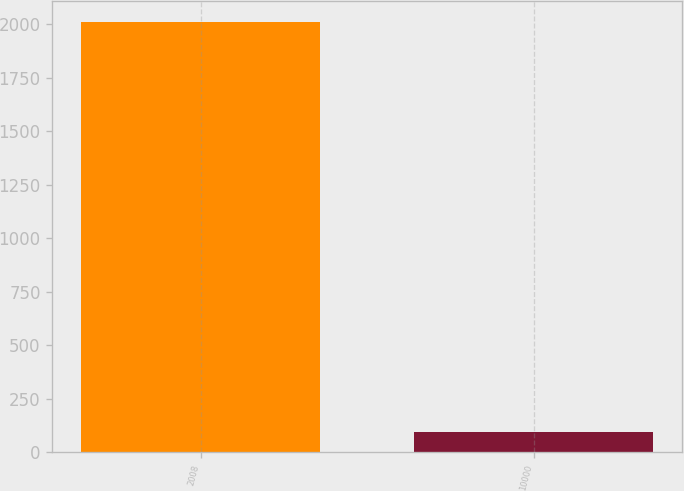<chart> <loc_0><loc_0><loc_500><loc_500><bar_chart><fcel>2008<fcel>10000<nl><fcel>2009<fcel>95.48<nl></chart> 